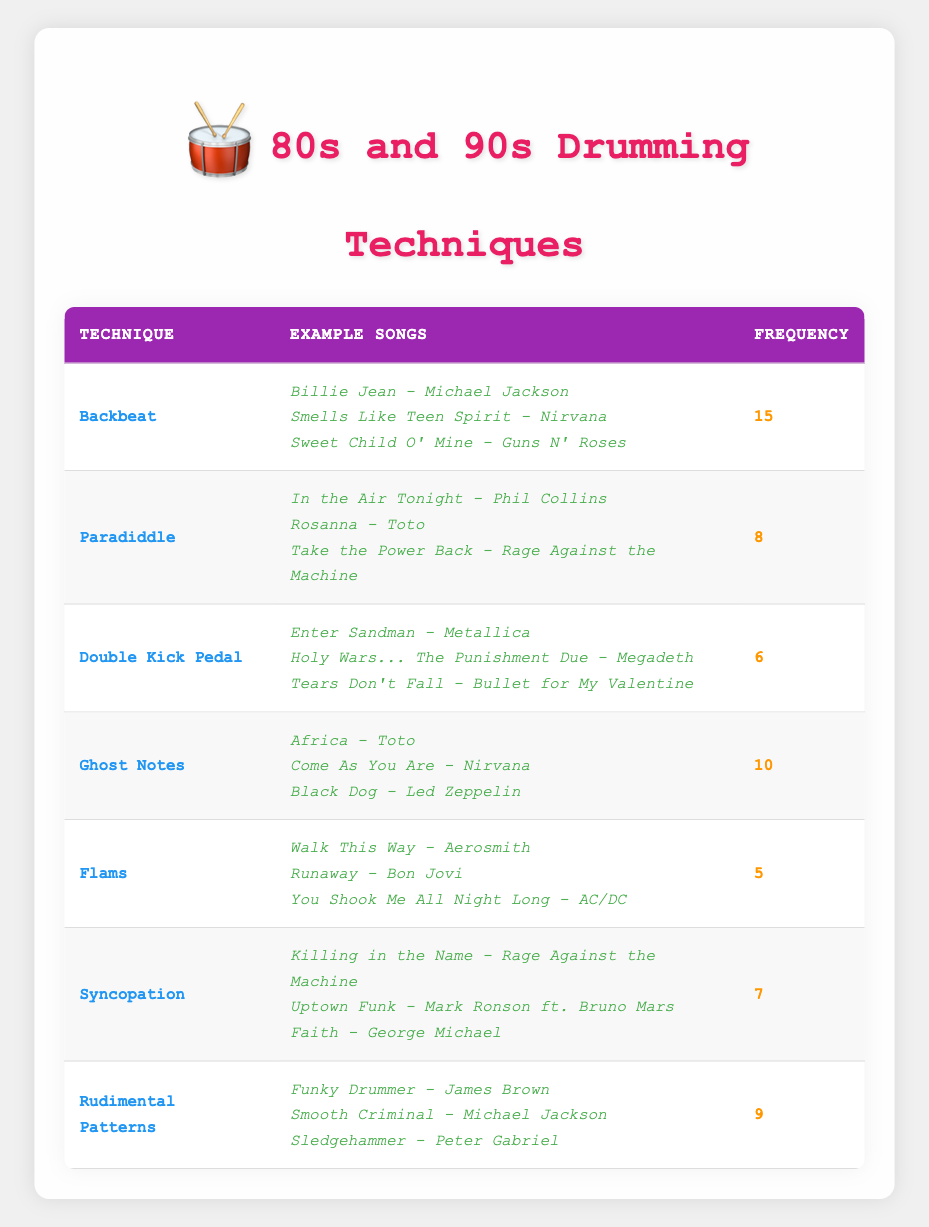What is the technique used most frequently in songs from the 80s and 90s? The highest frequency in the table is 15, corresponding to the technique "Backbeat." This can be found by scanning the frequency column for the highest number.
Answer: Backbeat How many songs utilize the "Ghost Notes" technique? There are three songs listed under the "Ghost Notes" technique: "Africa," "Come As You Are," and "Black Dog." This is simply counted from the songs column for that technique.
Answer: 3 Is "Double Kick Pedal" used more frequently than "Flams"? The frequency of "Double Kick Pedal" is 6, while "Flams" has a frequency of 5. Comparing these two values shows that "Double Kick Pedal" is indeed used more frequently than "Flams."
Answer: Yes What is the total frequency of all techniques in the table? To find the total frequency, add the frequencies of all techniques: 15 (Backbeat) + 8 (Paradiddle) + 6 (Double Kick Pedal) + 10 (Ghost Notes) + 5 (Flams) + 7 (Syncopation) + 9 (Rudimental Patterns) = 60. This calculation includes each frequency listed in the table.
Answer: 60 Which technique is associated with the most songs, and how many songs is it? The "Backbeat" technique is associated with three songs. By reviewing each technique's corresponding songs, that is the highest count observed.
Answer: 3 